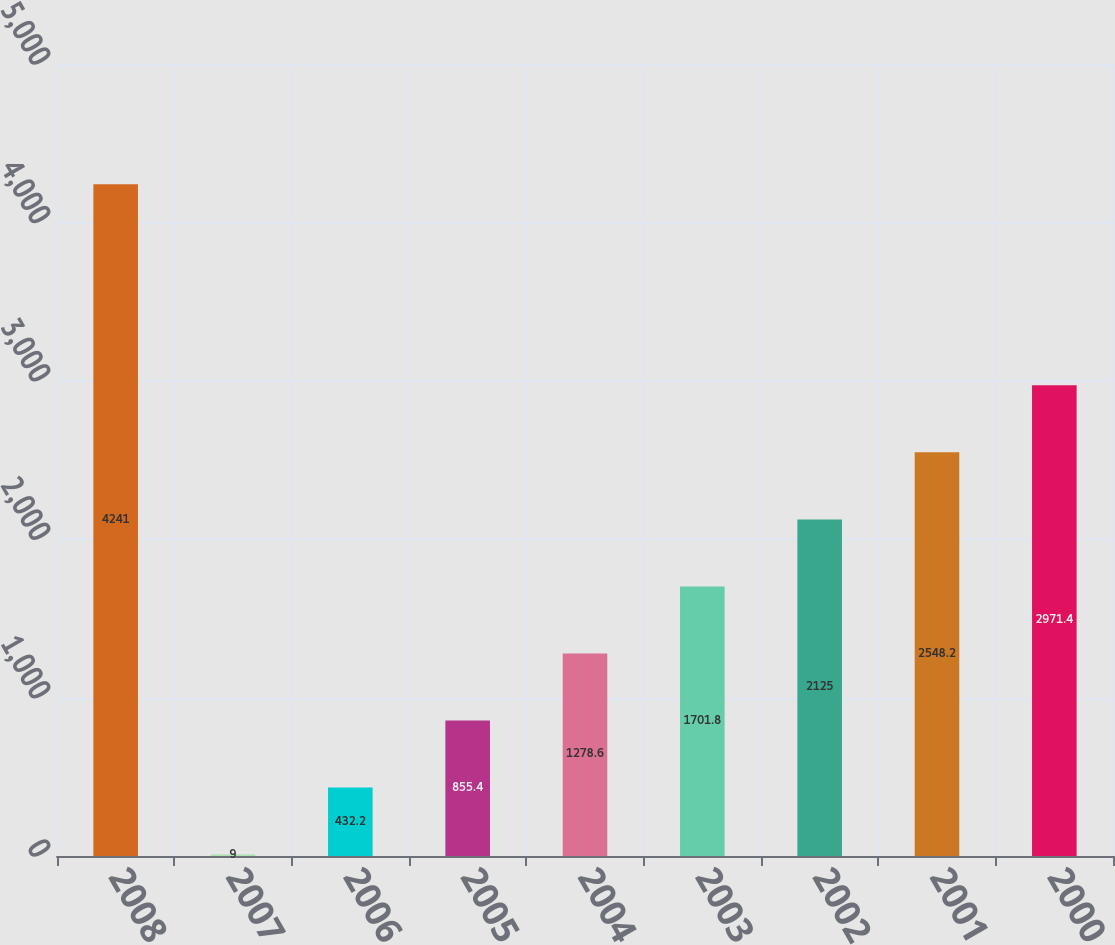Convert chart to OTSL. <chart><loc_0><loc_0><loc_500><loc_500><bar_chart><fcel>2008<fcel>2007<fcel>2006<fcel>2005<fcel>2004<fcel>2003<fcel>2002<fcel>2001<fcel>2000<nl><fcel>4241<fcel>9<fcel>432.2<fcel>855.4<fcel>1278.6<fcel>1701.8<fcel>2125<fcel>2548.2<fcel>2971.4<nl></chart> 